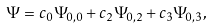<formula> <loc_0><loc_0><loc_500><loc_500>\Psi = c _ { 0 } \Psi _ { 0 , 0 } + c _ { 2 } \Psi _ { 0 , 2 } + c _ { 3 } \Psi _ { 0 , 3 } ,</formula> 